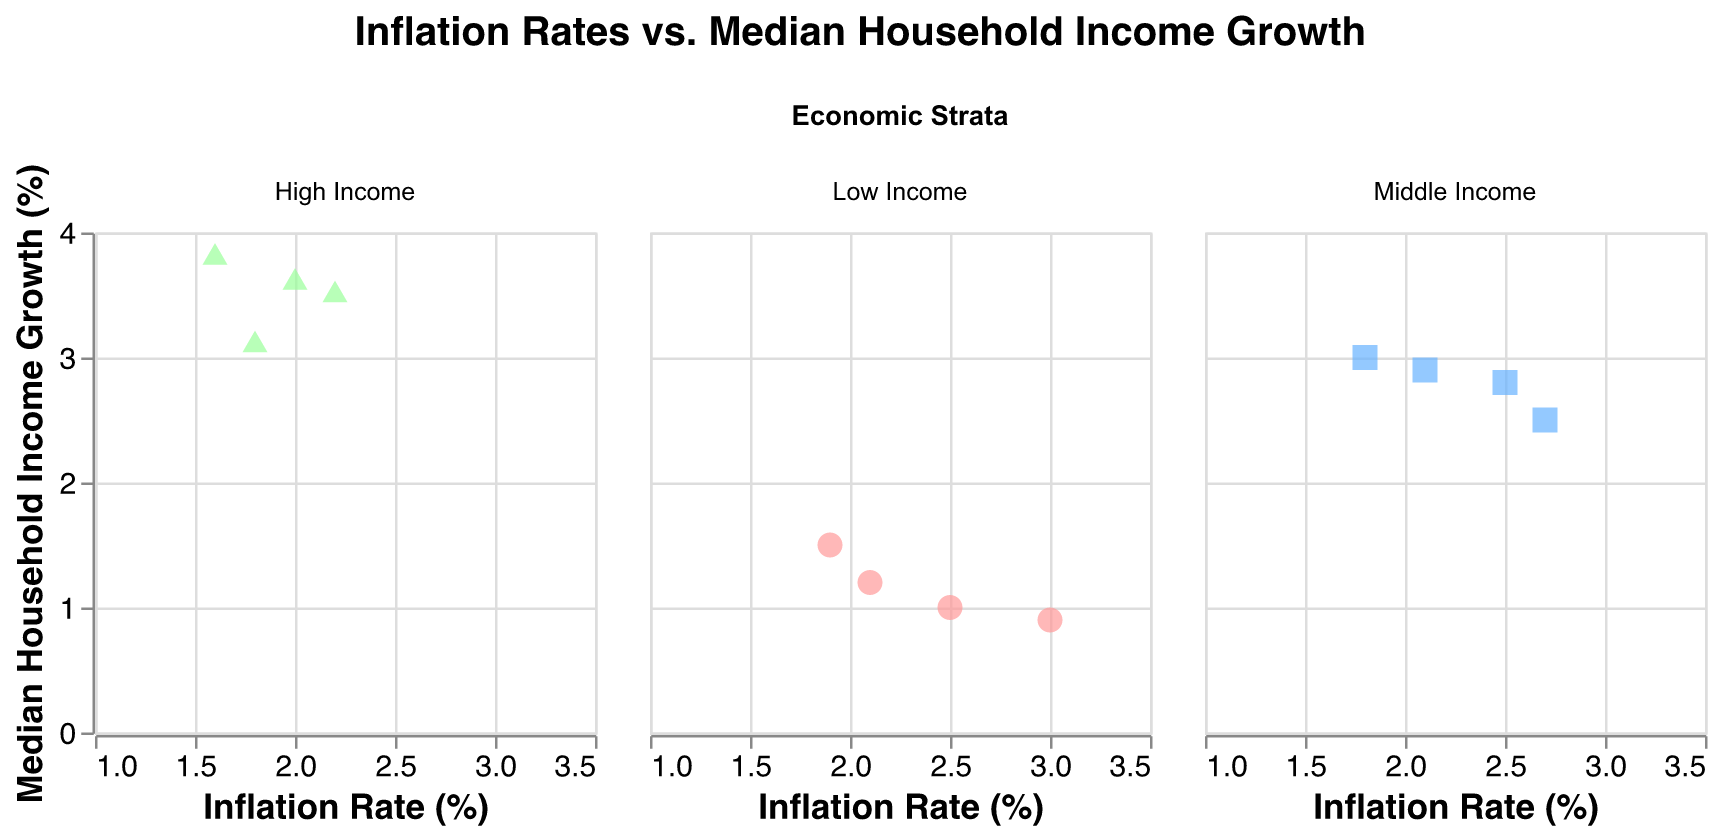What is the title of the figure? The title is positioned at the top of the figure and reads "Inflation Rates vs. Median Household Income Growth"
Answer: Inflation Rates vs. Median Household Income Growth How is the "Low Income" economic strata represented in the plot? The "Low Income" economic strata is represented with circle shapes and colored in a shade of red (pink).
Answer: Circles in red (pink) Which economic strata has the highest median household income growth? In the high-income stratum, the highest data point for median household income growth appears at approximately 3.8%.
Answer: High Income What is the general trend for median household income growth in the High-Income economic strata in relation to inflation rates? The trend can be observed as a general increase in median household income growth as the inflation rate decreases. This is evident because higher income growth rates align with lower inflation rates in the High-Income strata.
Answer: As inflation rates decrease, median household income growth tends to increase Which economic strata have the widest range of inflation rates represented? By observing the horizontal spread of the data points in each plot, the "Low Income" stratum has data points from around 1.9% to 3.0%, indicating the widest range of inflation rates.
Answer: Low Income Which economic strata data points are concentrated at lower inflation rates? The "High Income" strata data points are more concentrated at the lower inflation rates between 1.6% and 2.2%.
Answer: High Income Do the Middle Income or High Income strata show a direct correlation between inflation rate and median household income growth? In the Middle Income stratum, as inflation rates increase from 1.8% to 2.7%, median household income growth fluctuates within a range from 2.5% to 3.0%, which is less consistent. For the High Income stratum, as inflation rates increase, the median household income growth consistently ranges from 3.1% to 3.8%, indicating a more consistent trend relative to the Middle Income.
Answer: High Income shows more consistent correlation What is the range of median household income growth for the Middle Income stratum? Observing the vertical spread of the data points for Middle Income, the values range from around 2.5% to 3.0%.
Answer: 2.5% to 3.0% In which economic strata do the data points show the most clustering? Data points for the High Income stratum show the most clustering around lower inflation rates and higher median household income growth.
Answer: High Income Identify the economic strata where an inflation rate of 2.5% does not always correspond to similar median household income growth rates. In the Low Income stratum, an inflation rate of 2.5% corresponds to different median household income growth rates of 1.0% and 1.2%, indicating variability.
Answer: Low Income Which economic strata has the highest variability in median household income growth? By comparing the vertical spread of data points, "Low Income" has the highest variability in median household income growth, ranging from 0.9% to 1.5%.
Answer: Low Income 